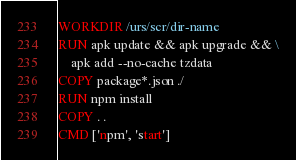<code> <loc_0><loc_0><loc_500><loc_500><_Dockerfile_>WORKDIR /urs/scr/dir-name
RUN apk update && apk upgrade && \
    apk add --no-cache tzdata
COPY package*.json ./
RUN npm install
COPY . .
CMD ['npm', 'start']</code> 